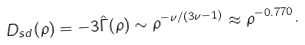Convert formula to latex. <formula><loc_0><loc_0><loc_500><loc_500>D _ { s d } ( \rho ) = - 3 \hat { \Gamma } ( \rho ) \sim \rho ^ { - \nu / ( 3 \nu - 1 ) } \approx \rho ^ { - 0 . 7 7 0 } .</formula> 